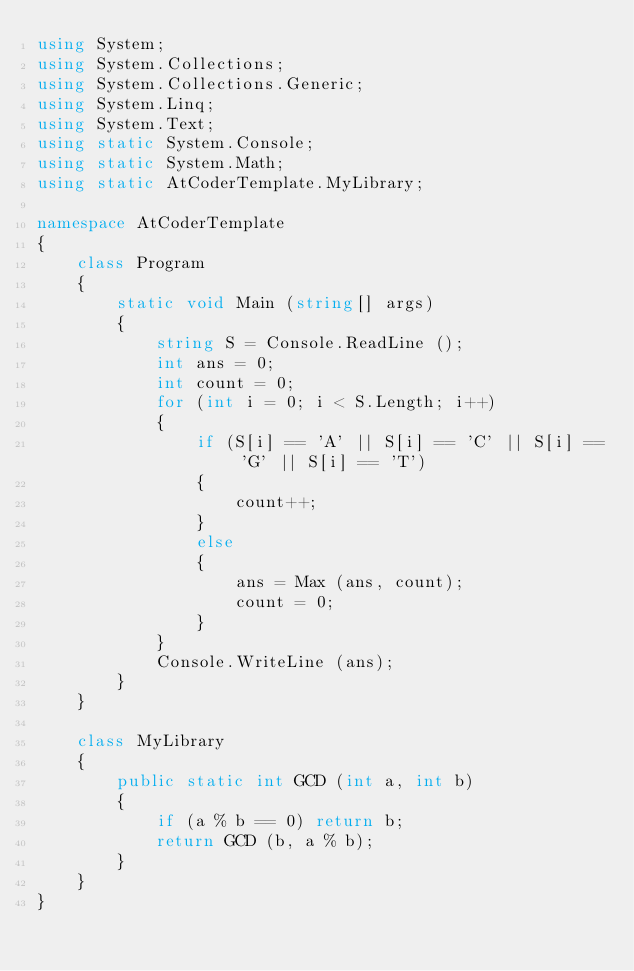Convert code to text. <code><loc_0><loc_0><loc_500><loc_500><_C#_>using System;
using System.Collections;
using System.Collections.Generic;
using System.Linq;
using System.Text;
using static System.Console;
using static System.Math;
using static AtCoderTemplate.MyLibrary;

namespace AtCoderTemplate
{
    class Program
    {
        static void Main (string[] args)
        {
            string S = Console.ReadLine ();
            int ans = 0;
            int count = 0;
            for (int i = 0; i < S.Length; i++)
            {
                if (S[i] == 'A' || S[i] == 'C' || S[i] == 'G' || S[i] == 'T')
                {
                    count++;
                }
                else
                {
                    ans = Max (ans, count);
                    count = 0;
                }
            }
            Console.WriteLine (ans);
        }
    }

    class MyLibrary
    {
        public static int GCD (int a, int b)
        {
            if (a % b == 0) return b;
            return GCD (b, a % b);
        }
    }
}</code> 